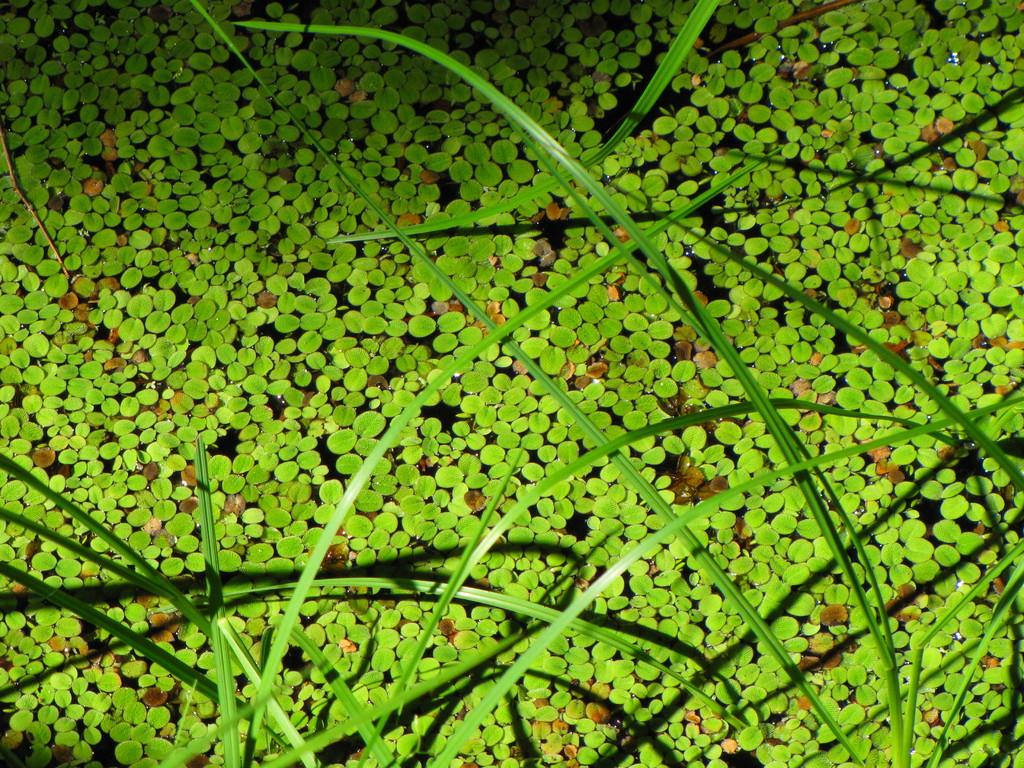What is floating in the water in the image? There are leaves in the water in the image. What else can be seen in the water besides leaves? There are plants in the water in the image. Where is the chalk located in the image? There is no chalk present in the image. What type of playground equipment can be seen in the image? There is no playground equipment present in the image. 